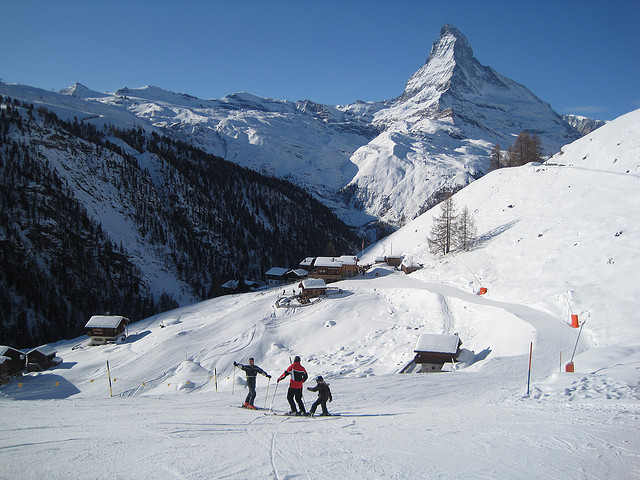What types of trees are these? A. evergreens B. oaks C. eucalyptus D. birches Answer with the option's letter from the given choices directly. There aren't any prominent trees visible in the image, which shows a snowy mountain landscape, presumably a ski slope, with a clear view of the iconic Matterhorn peak in the background. Therefore, the answer to the original question on tree types is not applicable in this context. 